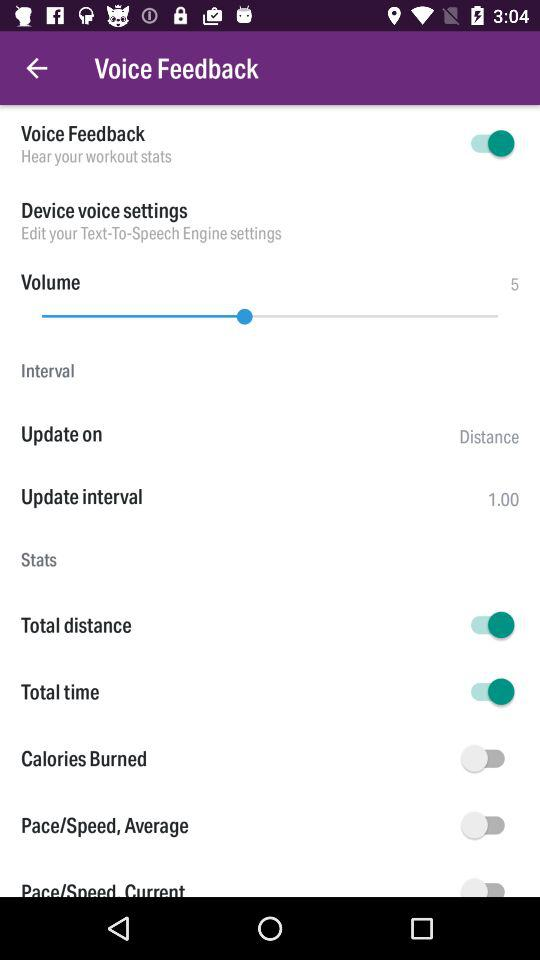How loud is the volume right now?
When the provided information is insufficient, respond with <no answer>. <no answer> 